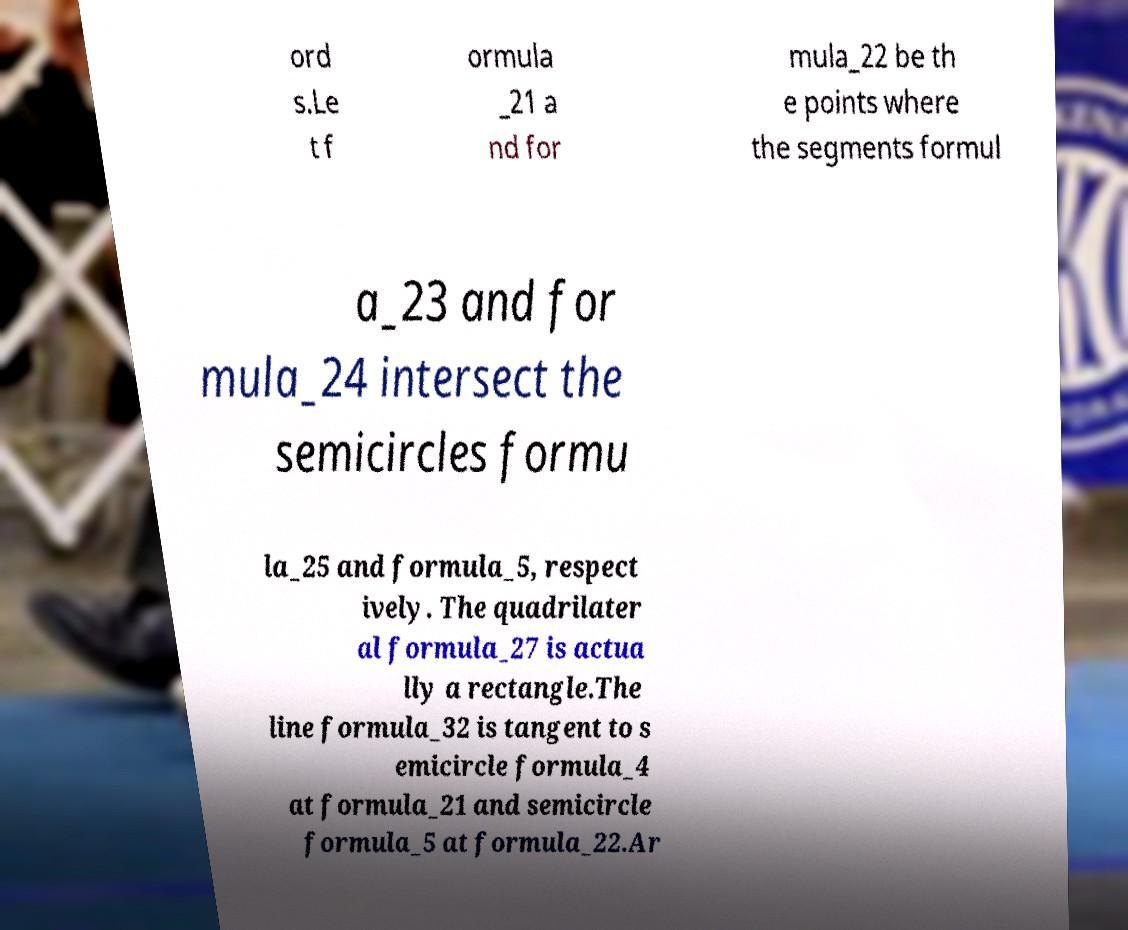For documentation purposes, I need the text within this image transcribed. Could you provide that? ord s.Le t f ormula _21 a nd for mula_22 be th e points where the segments formul a_23 and for mula_24 intersect the semicircles formu la_25 and formula_5, respect ively. The quadrilater al formula_27 is actua lly a rectangle.The line formula_32 is tangent to s emicircle formula_4 at formula_21 and semicircle formula_5 at formula_22.Ar 